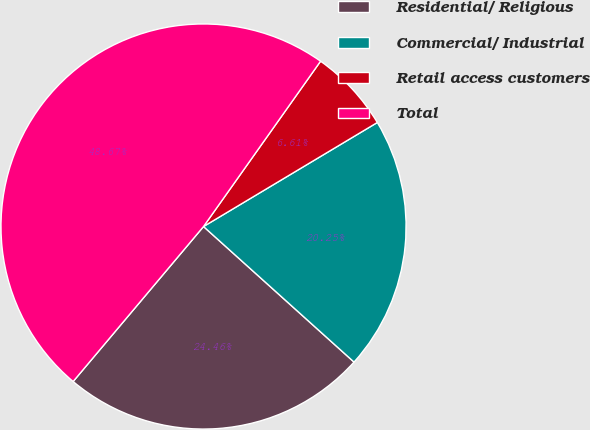Convert chart. <chart><loc_0><loc_0><loc_500><loc_500><pie_chart><fcel>Residential/ Religious<fcel>Commercial/ Industrial<fcel>Retail access customers<fcel>Total<nl><fcel>24.46%<fcel>20.25%<fcel>6.61%<fcel>48.67%<nl></chart> 